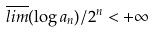<formula> <loc_0><loc_0><loc_500><loc_500>\overline { l i m } ( \log a _ { n } ) / 2 ^ { n } < + \infty</formula> 